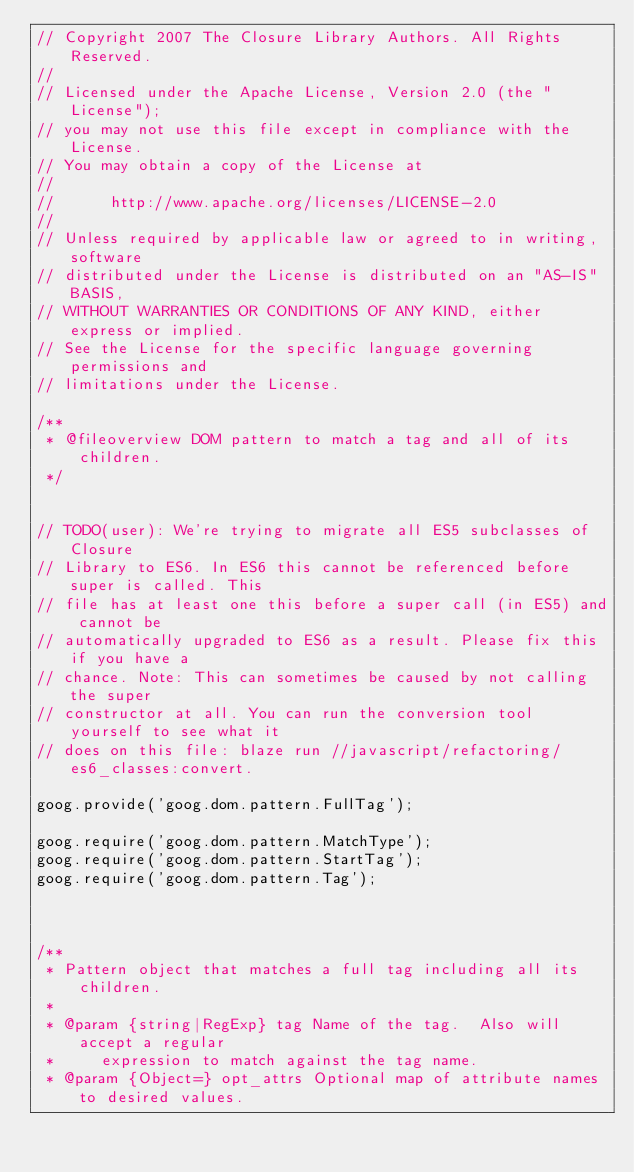<code> <loc_0><loc_0><loc_500><loc_500><_JavaScript_>// Copyright 2007 The Closure Library Authors. All Rights Reserved.
//
// Licensed under the Apache License, Version 2.0 (the "License");
// you may not use this file except in compliance with the License.
// You may obtain a copy of the License at
//
//      http://www.apache.org/licenses/LICENSE-2.0
//
// Unless required by applicable law or agreed to in writing, software
// distributed under the License is distributed on an "AS-IS" BASIS,
// WITHOUT WARRANTIES OR CONDITIONS OF ANY KIND, either express or implied.
// See the License for the specific language governing permissions and
// limitations under the License.

/**
 * @fileoverview DOM pattern to match a tag and all of its children.
 */


// TODO(user): We're trying to migrate all ES5 subclasses of Closure
// Library to ES6. In ES6 this cannot be referenced before super is called. This
// file has at least one this before a super call (in ES5) and cannot be
// automatically upgraded to ES6 as a result. Please fix this if you have a
// chance. Note: This can sometimes be caused by not calling the super
// constructor at all. You can run the conversion tool yourself to see what it
// does on this file: blaze run //javascript/refactoring/es6_classes:convert.

goog.provide('goog.dom.pattern.FullTag');

goog.require('goog.dom.pattern.MatchType');
goog.require('goog.dom.pattern.StartTag');
goog.require('goog.dom.pattern.Tag');



/**
 * Pattern object that matches a full tag including all its children.
 *
 * @param {string|RegExp} tag Name of the tag.  Also will accept a regular
 *     expression to match against the tag name.
 * @param {Object=} opt_attrs Optional map of attribute names to desired values.</code> 